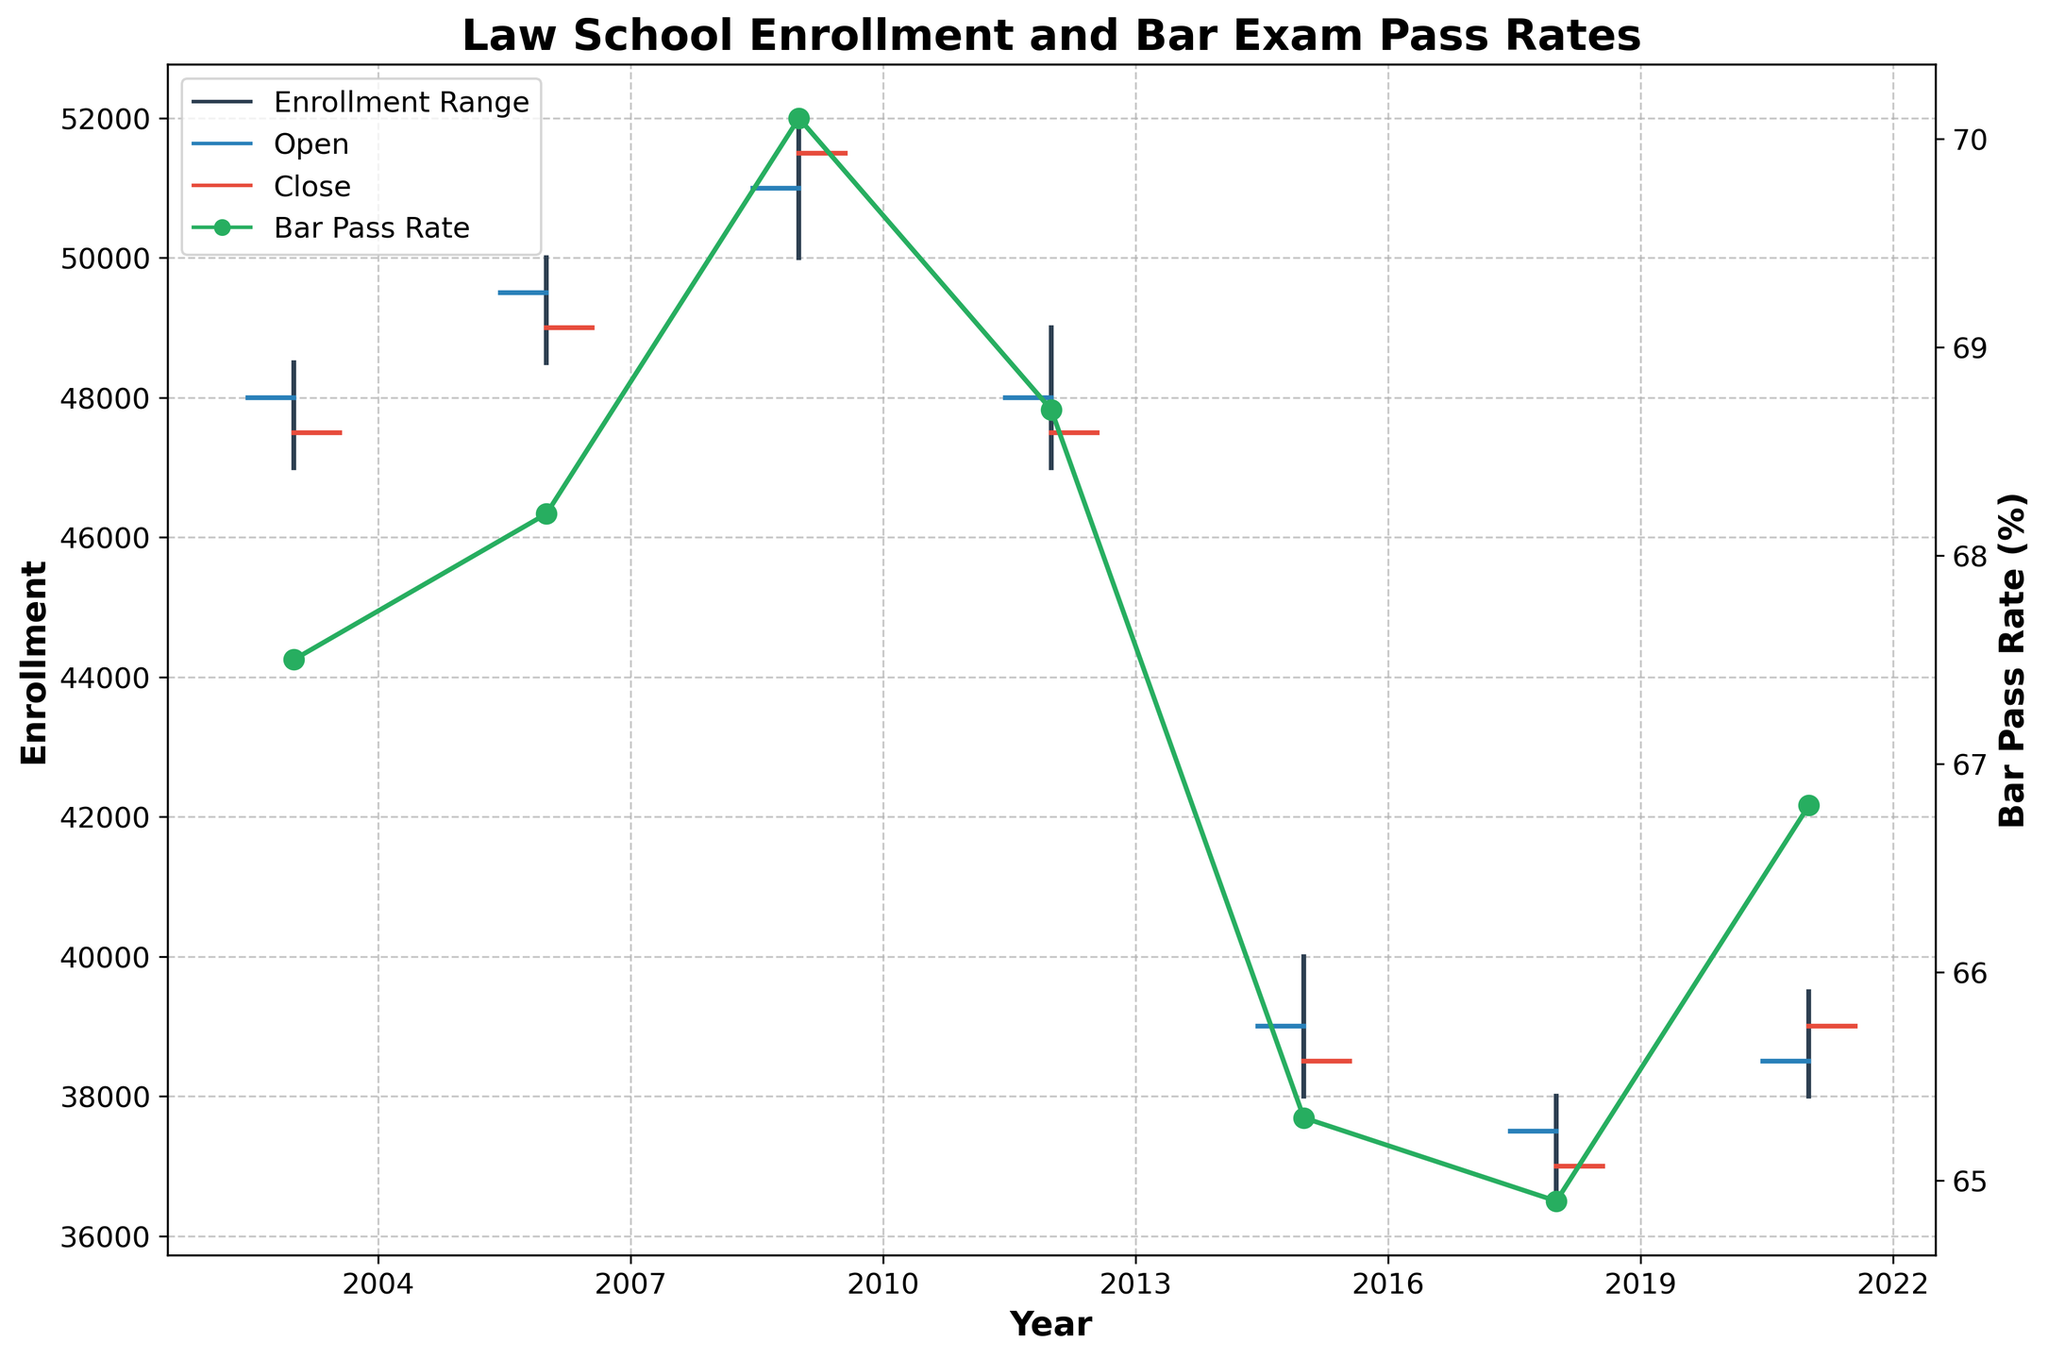What's the title of the plot? The title of the plot is located at the top and is set to provide an overview of the figure. In this case, it says "Law School Enrollment and Bar Exam Pass Rates".
Answer: Law School Enrollment and Bar Exam Pass Rates What do the vertical lines represent in the figure? The vertical lines indicate the range between the highest (High) and lowest (Low) enrollment values for each year.
Answer: Enrollment Range How many years are represented in the figure? Count the individual data points or vertical lines along the x-axis, as each represents one year. There are 7 data points from 2003 to 2021.
Answer: 7 In which year did the bar exam pass rate peak, and what was the rate? Look for the highest point on the secondary y-axis curve (green line with markers). The peak occurs in 2009 at a rate of 70.1%.
Answer: 2009, 70.1% Compare the enrollment closing values of 2012 and 2015. Which year had a lower closing value? The closing value can be found on the right-hand side of the horizontal segment connected to the crosshair. In 2012, it was 47,500 whereas in 2015, it was 38,500. Therefore, 2015 had a lower closing value.
Answer: 2015 What is the trend in law school enrollment from 2003 to 2018? Analyze the trend of the closing values over the years. The closing values decrease over time, indicating a downward trend in law school enrollment.
Answer: Downward Trend How much did the bar pass rate change from 2015 to 2021? Subtract the 2015 bar pass rate (65.3%) from the 2021 rate (66.8%). The change is 66.8% - 65.3% = 1.5%.
Answer: 1.5% In which year is the difference between the high and low enrollment values the smallest? Calculate the range (high value minus low value) for each year. Compare these differences to identify the smallest one. In 2018, the difference is 15,000 - the smallest among all years.
Answer: 2018 How does the closing enrollment value in 2009 compare to that in 2003? Refer to the horizontal segments at the end of the crosshairs for 2009 (51,500) and 2003 (47,500). 2009 has a higher closing value compared to 2003.
Answer: 2009 is higher 